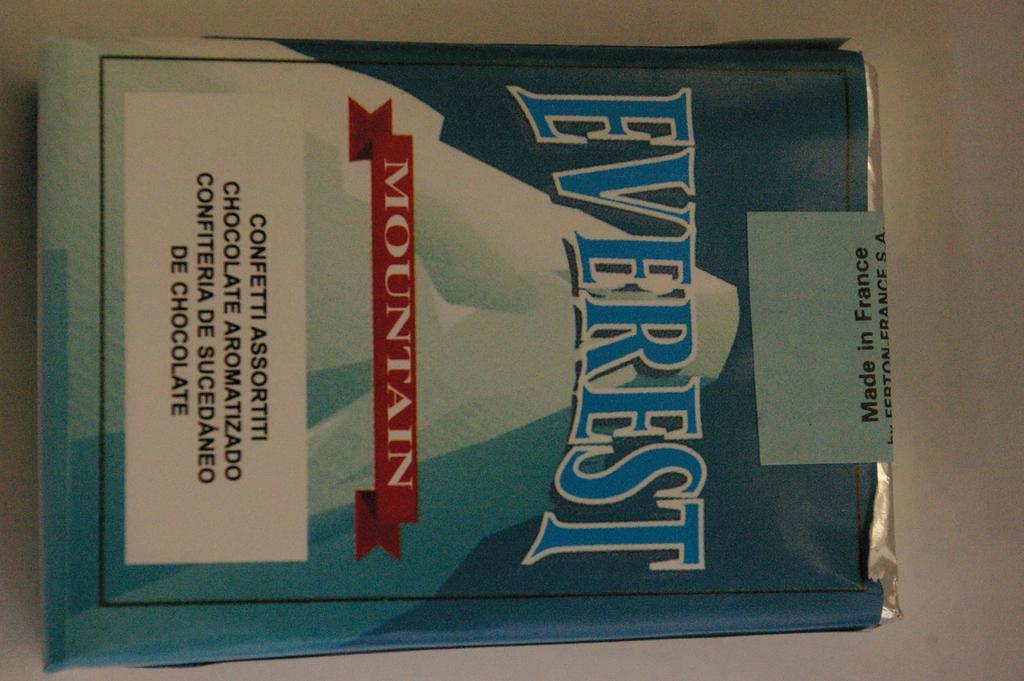What is the name of the mountain?
Give a very brief answer. Everest. 